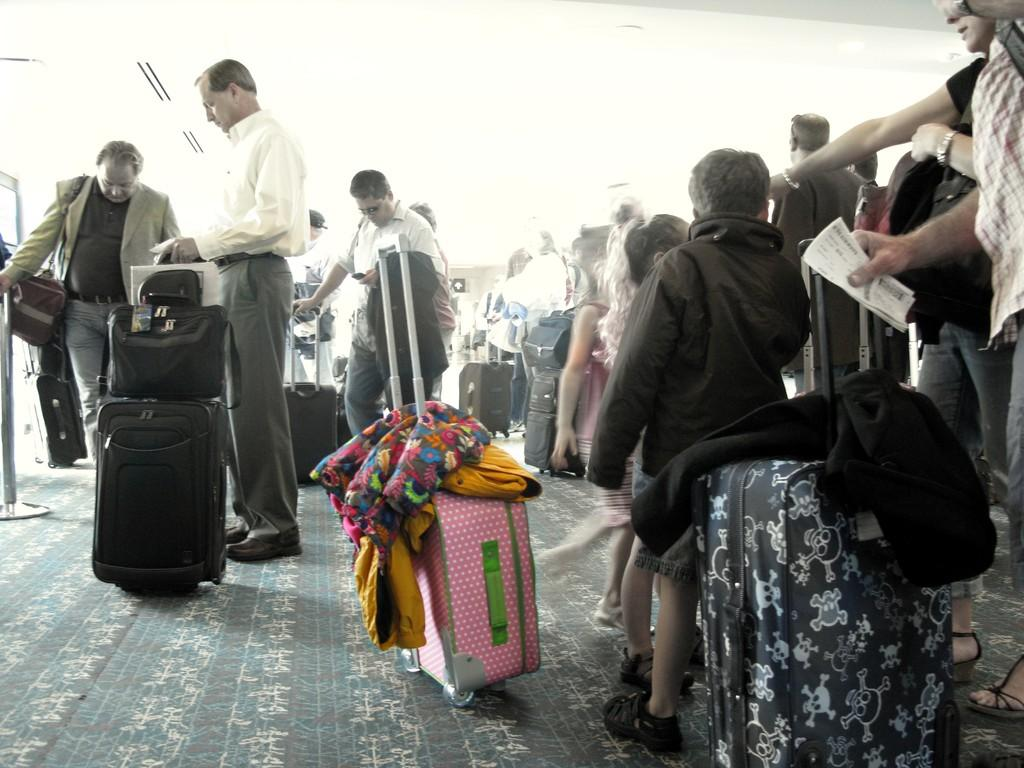How many people are visible in the image? There are many people standing in the image. What are some people holding in their hands? Some people are holding bags in their hands. What type of bags can be seen in the image? There are many trolley bags in the image. What is placed on the trolley bags? Clothes are present on the trolley bags. How many cattle can be seen grazing in the image? There are no cattle present in the image; it features people standing and holding bags. What is the thumbprint of the person holding the bag in the image? There is no thumbprint visible in the image, as it is a photograph and not a fingerprint scan. 